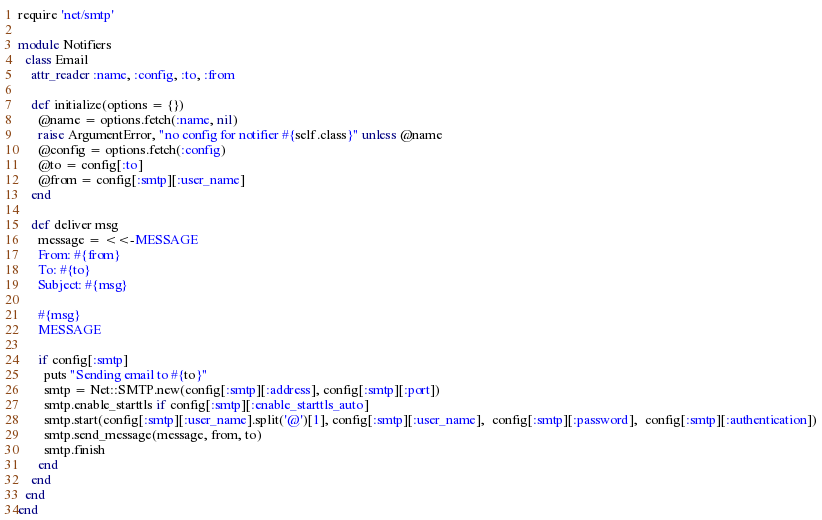Convert code to text. <code><loc_0><loc_0><loc_500><loc_500><_Ruby_>require 'net/smtp'

module Notifiers
  class Email
    attr_reader :name, :config, :to, :from

    def initialize(options = {})
      @name = options.fetch(:name, nil)
      raise ArgumentError, "no config for notifier #{self.class}" unless @name
      @config = options.fetch(:config)
      @to = config[:to]
      @from = config[:smtp][:user_name]
    end

    def deliver msg
      message = <<-MESSAGE
      From: #{from}
      To: #{to}
      Subject: #{msg}

      #{msg}
      MESSAGE

      if config[:smtp]
        puts "Sending email to #{to}"
        smtp = Net::SMTP.new(config[:smtp][:address], config[:smtp][:port])
        smtp.enable_starttls if config[:smtp][:enable_starttls_auto]
        smtp.start(config[:smtp][:user_name].split('@')[1], config[:smtp][:user_name],  config[:smtp][:password],  config[:smtp][:authentication])
        smtp.send_message(message, from, to)
        smtp.finish
      end
    end
  end
end
</code> 